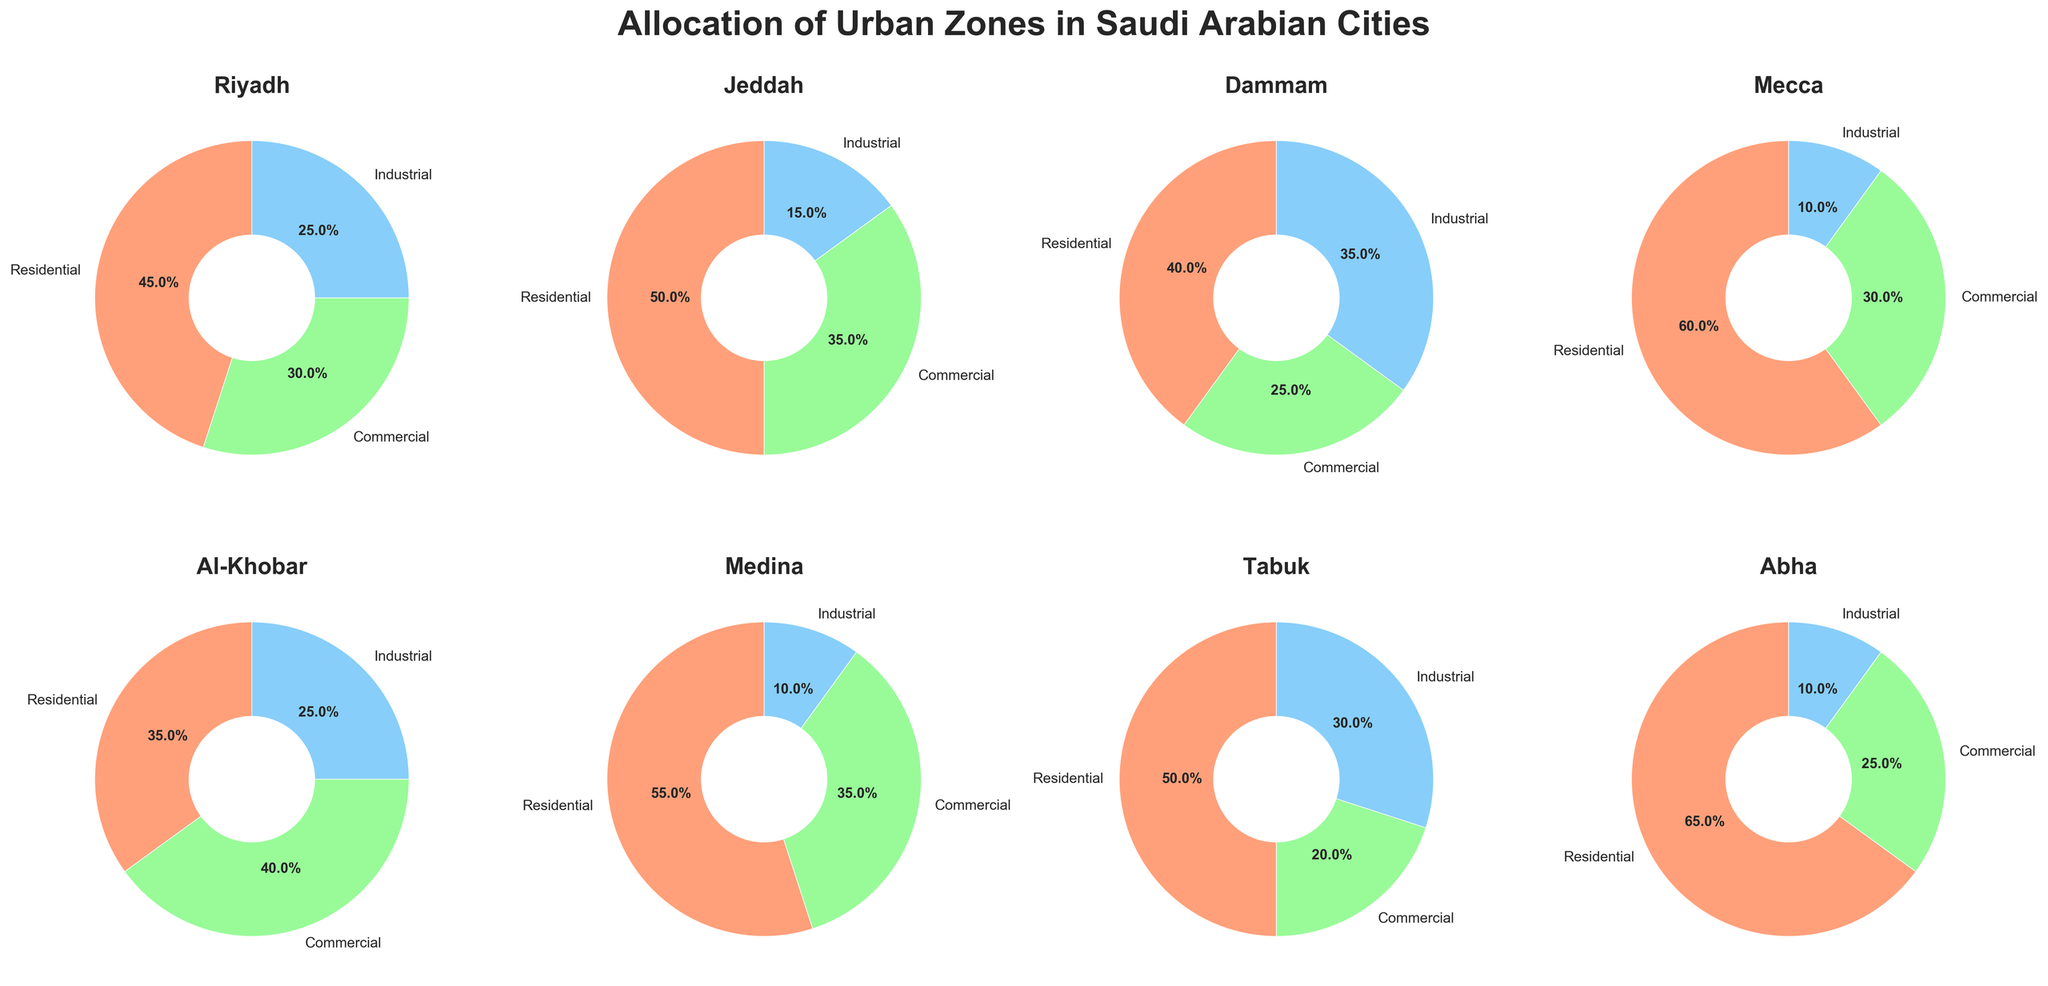How many cities are displayed in the plot? Count the number of pie charts shown in the figure. There are pie charts for Riyadh, Jeddah, Dammam, Mecca, Al-Khobar, Medina, Tabuk, and Abha.
Answer: 8 What is the title of the plot? The title is located at the top of the entire figure.
Answer: Allocation of Urban Zones in Saudi Arabian Cities Which city has the highest percentage of residential zones? Look for the pie chart where the residential slice (often marked in a distinct color) has the largest percentage. Abha has the residential zone with 65%.
Answer: Abha What is the proportion of commercial zones in Al-Khobar? Find the pie chart for Al-Khobar and check the percentage of the commercial portion. Al-Khobar's commercial portion is 40%.
Answer: 40% Compare the percentage of industrial zones between Dammam and Tabuk. Which city has a higher percentage? Identify the pie charts for Dammam and Tabuk; check their industrial portions. Dammam has 35%, and Tabuk has 30%. Hence, Dammam has a higher percentage.
Answer: Dammam Which city has the lowest percentage of industrial zones? Look for the city with the smallest industrial portion in its pie chart. Mecca and Medina both have industrial zones of 10%.
Answer: Mecca or Medina What is the total percentage of zones (residential, commercial, and industrial) in Medina? Sum the percentages of the residential, commercial, and industrial zones for Medina. These are 55%, 35%, and 10%, respectively, and the total is 55 + 35 + 10 = 100%.
Answer: 100% Compare the residential and commercial zones in Jeddah. By how much does the residential percentage exceed the commercial percentage? Look at the pie chart for Jeddah; residential is 50%, and commercial is 35%. The difference is 50 - 35 = 15%.
Answer: 15% What is the average percentage of residential zones across all cities? Calculate the average by summing the residential percentages of all cities and dividing by the number of cities: (45 + 50 + 40 + 60 + 35 + 55 + 50 + 65) / 8 = 50%.
Answer: 50% Identify the city with the most balanced allocation between residential, commercial, and industrial zones. Explain. For a balanced allocation, the percentages should be roughly equal. Look for the city where the three categories are closest in value. Riyadh has the closest values: Residential 45%, Commercial 30%, Industrial 25%.
Answer: Riyadh 